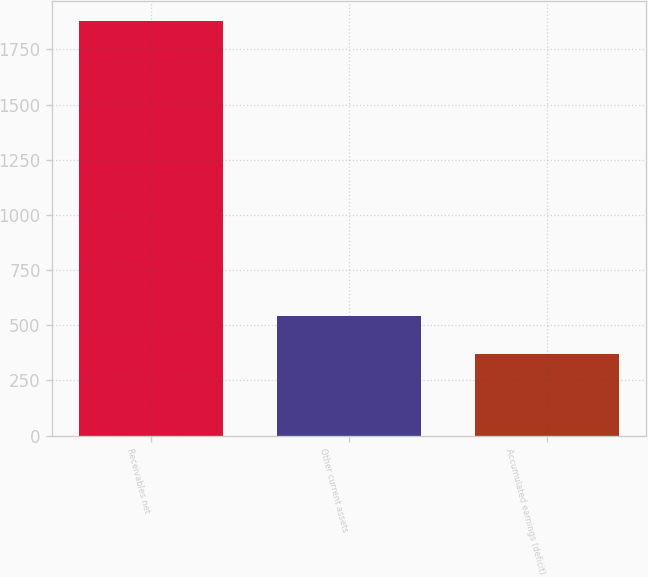Convert chart. <chart><loc_0><loc_0><loc_500><loc_500><bar_chart><fcel>Receivables net<fcel>Other current assets<fcel>Accumulated earnings (deficit)<nl><fcel>1877<fcel>543<fcel>372<nl></chart> 